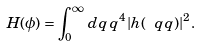Convert formula to latex. <formula><loc_0><loc_0><loc_500><loc_500>H ( \phi ) = \int _ { 0 } ^ { \infty } \, d q \, q ^ { 4 } | h ( \ q q ) | ^ { 2 } .</formula> 